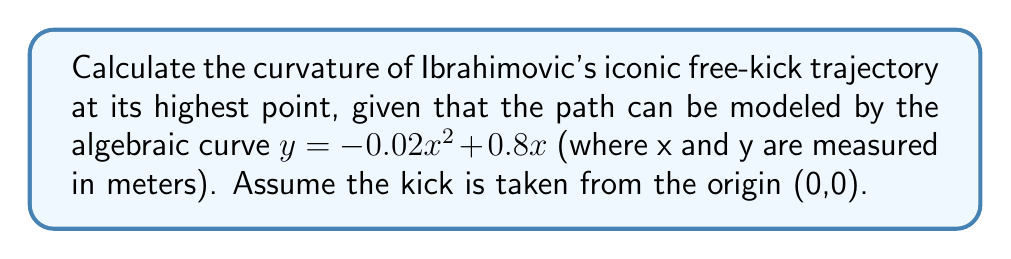Could you help me with this problem? To calculate the curvature of Ibrahimovic's free-kick trajectory, we'll follow these steps:

1) The curvature κ of a curve $y = f(x)$ at any point is given by:

   $$κ = \frac{|f''(x)|}{(1 + [f'(x)]^2)^{3/2}}$$

2) First, let's find $f'(x)$ and $f''(x)$:
   
   $f(x) = -0.02x^2 + 0.8x$
   $f'(x) = -0.04x + 0.8$
   $f''(x) = -0.04$

3) The highest point of the trajectory occurs when $f'(x) = 0$:

   $-0.04x + 0.8 = 0$
   $x = 20$ meters

4) At $x = 20$, $y = -0.02(20)^2 + 0.8(20) = 8$ meters

5) Now, let's substitute these values into the curvature formula:

   $$κ = \frac{|-0.04|}{(1 + [-0.04(20) + 0.8]^2)^{3/2}}$$

   $$κ = \frac{0.04}{(1 + 0^2)^{3/2}} = 0.04$$

6) Therefore, the curvature at the highest point of Ibrahimovic's free-kick trajectory is 0.04 m^(-1).
Answer: $0.04$ m^(-1) 